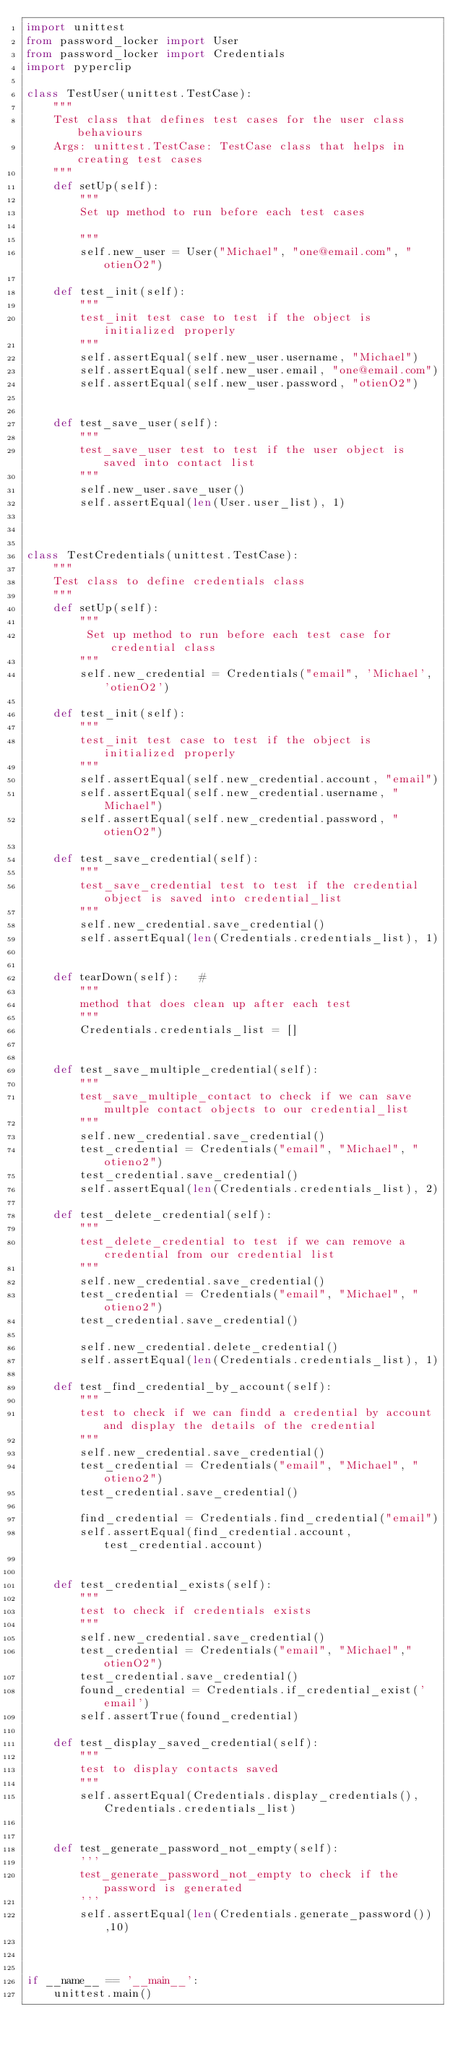Convert code to text. <code><loc_0><loc_0><loc_500><loc_500><_Python_>import unittest
from password_locker import User
from password_locker import Credentials
import pyperclip

class TestUser(unittest.TestCase):
    """
    Test class that defines test cases for the user class behaviours
    Args: unittest.TestCase: TestCase class that helps in creating test cases
    """
    def setUp(self):
        """
        Set up method to run before each test cases

        """
        self.new_user = User("Michael", "one@email.com", "otienO2")

    def test_init(self):
        """
        test_init test case to test if the object is initialized properly
        """
        self.assertEqual(self.new_user.username, "Michael")
        self.assertEqual(self.new_user.email, "one@email.com")
        self.assertEqual(self.new_user.password, "otienO2")


    def test_save_user(self):
        """
        test_save_user test to test if the user object is saved into contact list
        """
        self.new_user.save_user()
        self.assertEqual(len(User.user_list), 1)



class TestCredentials(unittest.TestCase):
    """
    Test class to define credentials class
    """
    def setUp(self):
        """
         Set up method to run before each test case for credential class
        """
        self.new_credential = Credentials("email", 'Michael', 'otienO2')

    def test_init(self):
        """
        test_init test case to test if the object is initialized properly
        """
        self.assertEqual(self.new_credential.account, "email")
        self.assertEqual(self.new_credential.username, "Michael")
        self.assertEqual(self.new_credential.password, "otienO2")

    def test_save_credential(self):
        """
        test_save_credential test to test if the credential object is saved into credential_list
        """
        self.new_credential.save_credential()
        self.assertEqual(len(Credentials.credentials_list), 1)


    def tearDown(self):   #
        """
        method that does clean up after each test
        """
        Credentials.credentials_list = []


    def test_save_multiple_credential(self):
        """
        test_save_multiple_contact to check if we can save multple contact objects to our credential_list
        """
        self.new_credential.save_credential()
        test_credential = Credentials("email", "Michael", "otieno2")
        test_credential.save_credential()
        self.assertEqual(len(Credentials.credentials_list), 2)

    def test_delete_credential(self):
        """
        test_delete_credential to test if we can remove a credential from our credential list
        """
        self.new_credential.save_credential()
        test_credential = Credentials("email", "Michael", "otieno2")
        test_credential.save_credential()

        self.new_credential.delete_credential()
        self.assertEqual(len(Credentials.credentials_list), 1)

    def test_find_credential_by_account(self):
        """
        test to check if we can findd a credential by account and display the details of the credential
        """
        self.new_credential.save_credential()
        test_credential = Credentials("email", "Michael", "otieno2")
        test_credential.save_credential()

        find_credential = Credentials.find_credential("email")
        self.assertEqual(find_credential.account, test_credential.account)


    def test_credential_exists(self):
        """
        test to check if credentials exists
        """
        self.new_credential.save_credential()
        test_credential = Credentials("email", "Michael","otienO2")
        test_credential.save_credential()
        found_credential = Credentials.if_credential_exist('email')
        self.assertTrue(found_credential)

    def test_display_saved_credential(self):
        """
        test to display contacts saved
        """
        self.assertEqual(Credentials.display_credentials(), Credentials.credentials_list)


    def test_generate_password_not_empty(self):
        '''
        test_generate_password_not_empty to check if the password is generated
        '''
        self.assertEqual(len(Credentials.generate_password()),10)
        

    
if __name__ == '__main__':
    unittest.main()
</code> 